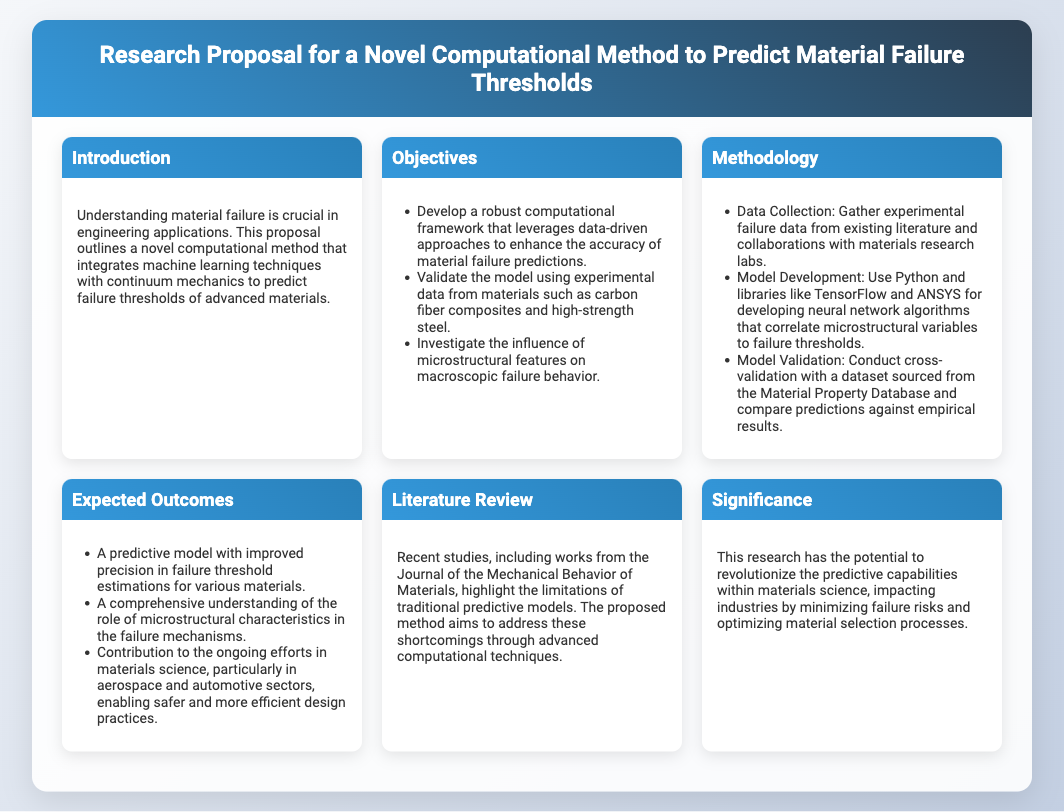what is the title of the research proposal? The title is found at the top of the document, summarizing the purpose and focus of the research.
Answer: Research Proposal for a Novel Computational Method to Predict Material Failure Thresholds how many objectives are listed in the proposal? The number of objectives can be found in the Objectives section, counting each listed item.
Answer: Three what programming languages are mentioned for model development? The programming languages used for model development are specified in the Methodology section.
Answer: Python which materials will the model validate against? The specific materials used for validation are mentioned in the Objectives section, providing clarity on the focus.
Answer: Carbon fiber composites and high-strength steel what is the main significance of the research? The significance of the research explains its potential impact on industries and material science, summarizing its contributions.
Answer: Revolutionize predictive capabilities what advanced techniques does the proposal aim to integrate? The integration of techniques is highlighted in the Introduction, demonstrating the innovative approach of the proposed method.
Answer: Machine learning techniques with continuum mechanics what will the predictive model improve? The expected improvements of the predictive model can be found in the Expected Outcomes section, outlining its impact on specific estimations.
Answer: Precision in failure threshold estimations how is the model validated? The method of validation is detailed in the Methodology section, explaining the comparative approach to verification.
Answer: Cross-validation with a dataset what sector will benefit from this research? The specific sectors benefiting from this research are identified in the Expected Outcomes section, indicating practical applications.
Answer: Aerospace and automotive sectors 